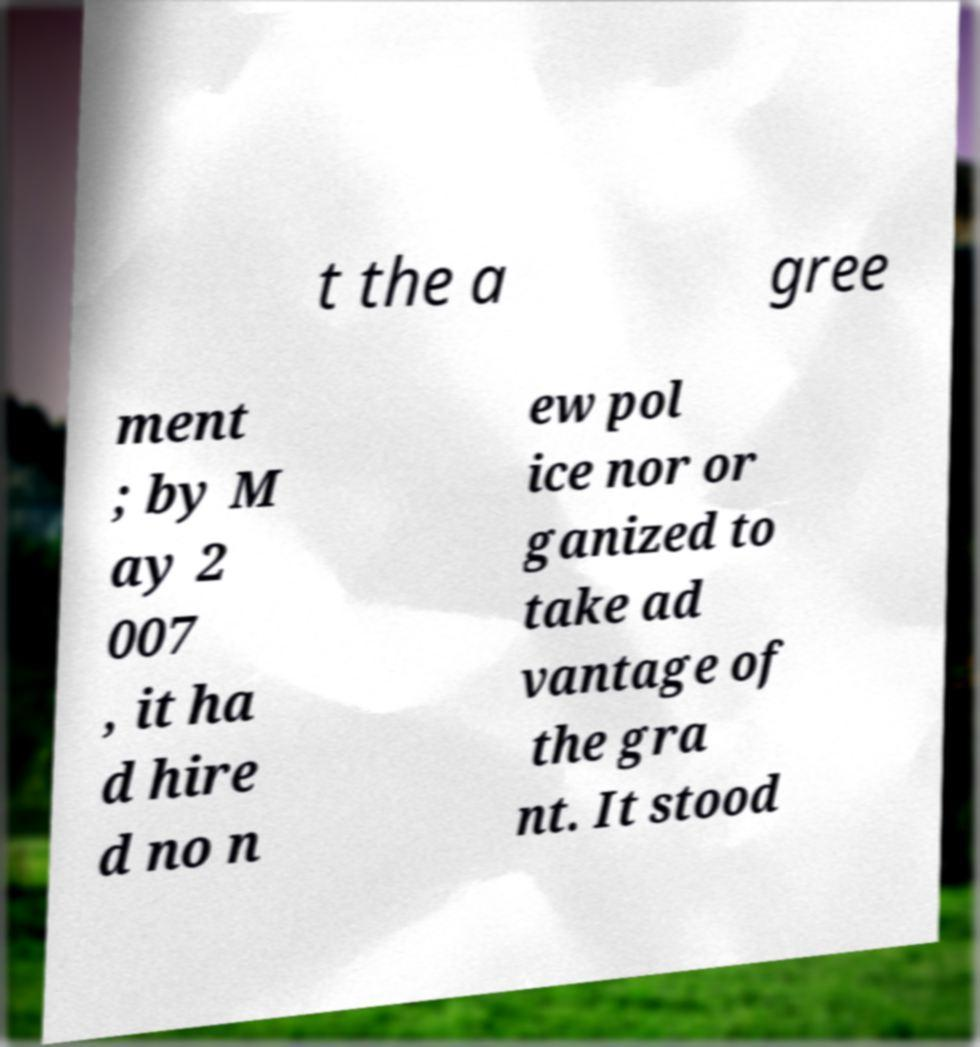There's text embedded in this image that I need extracted. Can you transcribe it verbatim? t the a gree ment ; by M ay 2 007 , it ha d hire d no n ew pol ice nor or ganized to take ad vantage of the gra nt. It stood 